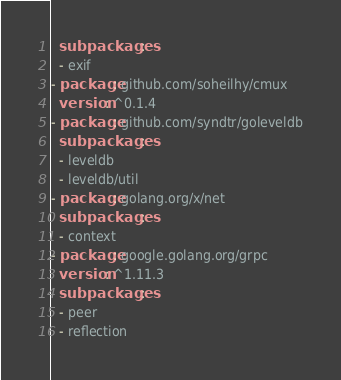<code> <loc_0><loc_0><loc_500><loc_500><_YAML_>  subpackages:
  - exif
- package: github.com/soheilhy/cmux
  version: ^0.1.4
- package: github.com/syndtr/goleveldb
  subpackages:
  - leveldb
  - leveldb/util
- package: golang.org/x/net
  subpackages:
  - context
- package: google.golang.org/grpc
  version: ^1.11.3
  subpackages:
  - peer
  - reflection
</code> 